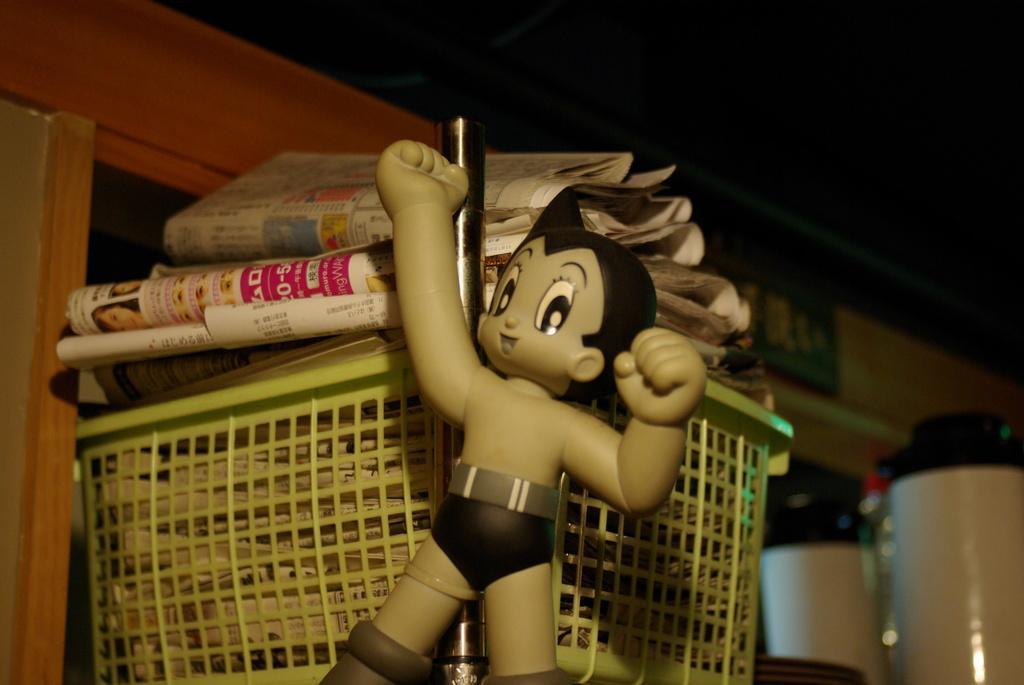Can you describe this image briefly? In the center of the image there is a toy. In the background there is a basket and papers placed in it and there is a wall. 